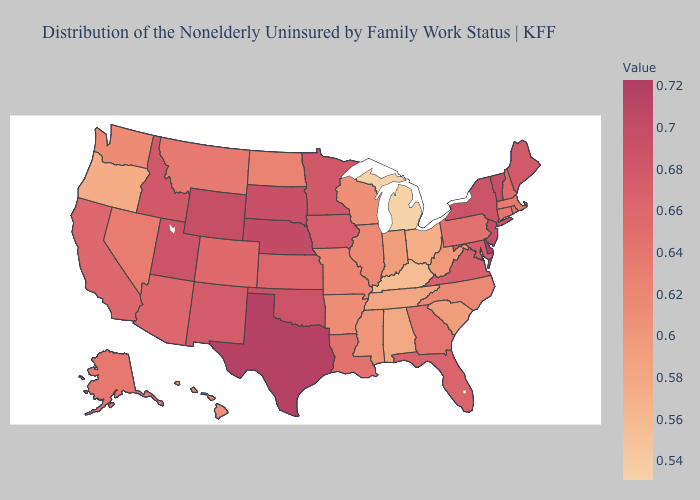Does Nebraska have the highest value in the MidWest?
Keep it brief. Yes. Does Delaware have the highest value in the USA?
Be succinct. Yes. Among the states that border Utah , which have the lowest value?
Be succinct. Nevada. Among the states that border Indiana , does Illinois have the highest value?
Give a very brief answer. Yes. Does Texas have a lower value than North Carolina?
Be succinct. No. Does Michigan have the lowest value in the USA?
Keep it brief. Yes. 